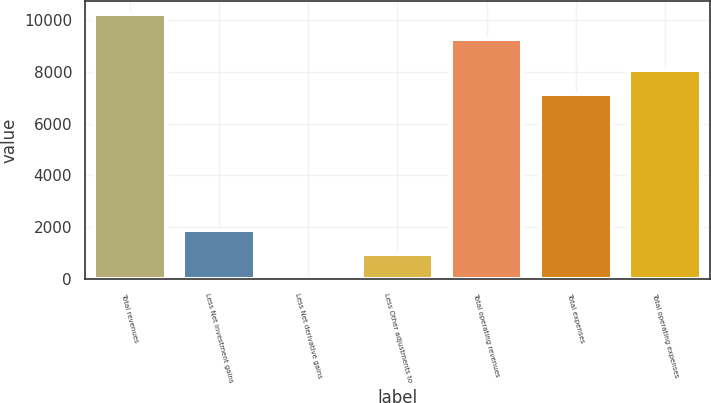Convert chart to OTSL. <chart><loc_0><loc_0><loc_500><loc_500><bar_chart><fcel>Total revenues<fcel>Less Net investment gains<fcel>Less Net derivative gains<fcel>Less Other adjustments to<fcel>Total operating revenues<fcel>Total expenses<fcel>Total operating expenses<nl><fcel>10222.4<fcel>1913.8<fcel>17<fcel>965.4<fcel>9274<fcel>7134<fcel>8082.4<nl></chart> 